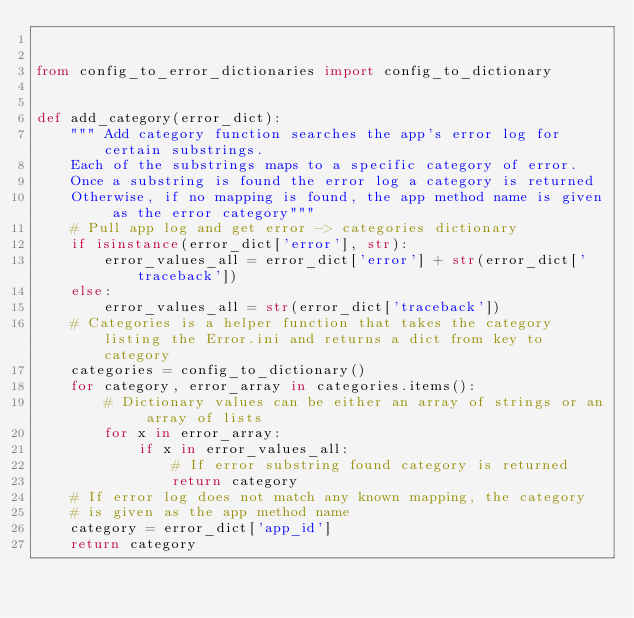<code> <loc_0><loc_0><loc_500><loc_500><_Python_>

from config_to_error_dictionaries import config_to_dictionary


def add_category(error_dict):
    """ Add category function searches the app's error log for certain substrings.
    Each of the substrings maps to a specific category of error.
    Once a substring is found the error log a category is returned
    Otherwise, if no mapping is found, the app method name is given as the error category"""
    # Pull app log and get error -> categories dictionary
    if isinstance(error_dict['error'], str):
        error_values_all = error_dict['error'] + str(error_dict['traceback'])
    else:
        error_values_all = str(error_dict['traceback'])
    # Categories is a helper function that takes the category listing the Error.ini and returns a dict from key to category
    categories = config_to_dictionary()
    for category, error_array in categories.items():
        # Dictionary values can be either an array of strings or an array of lists
        for x in error_array:
            if x in error_values_all:
                # If error substring found category is returned
                return category
    # If error log does not match any known mapping, the category
    # is given as the app method name
    category = error_dict['app_id']
    return category
</code> 